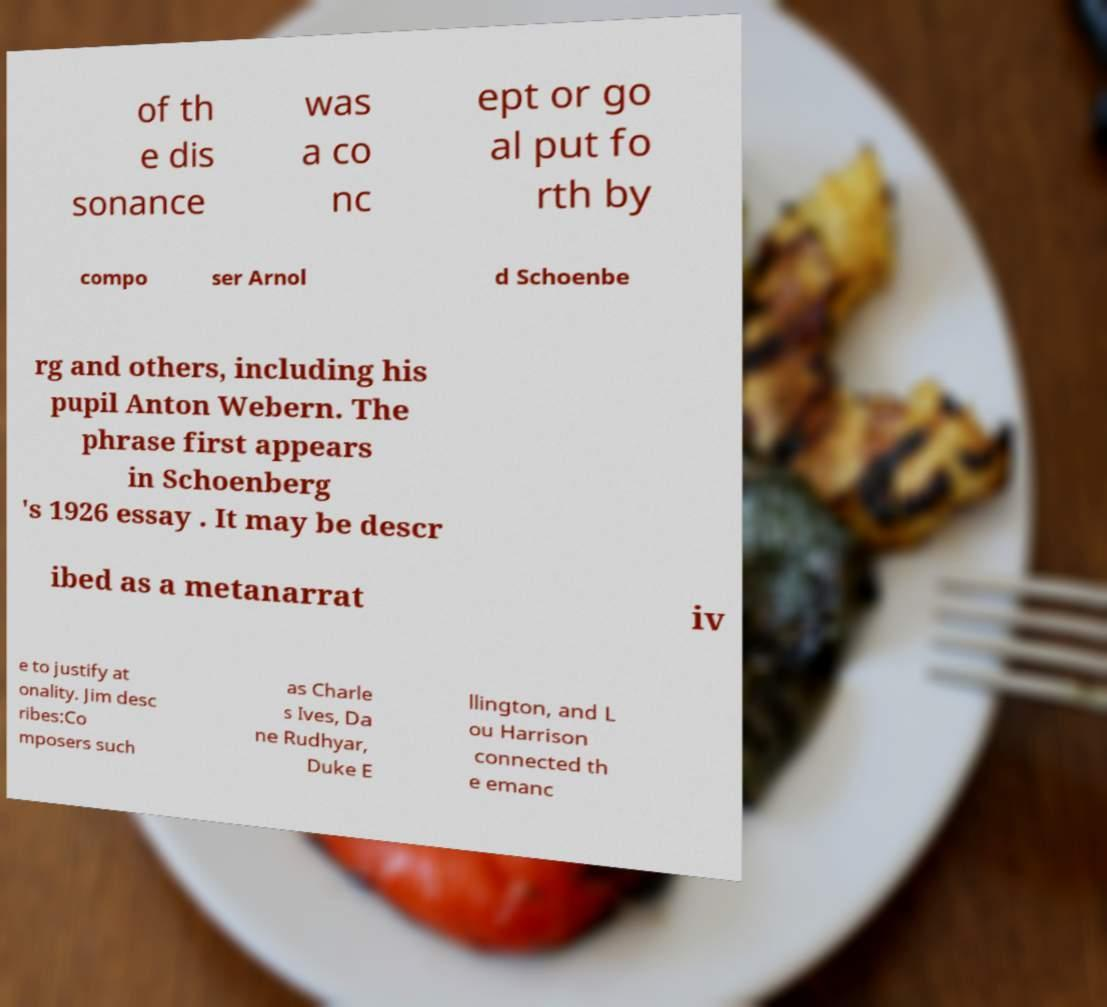Can you accurately transcribe the text from the provided image for me? of th e dis sonance was a co nc ept or go al put fo rth by compo ser Arnol d Schoenbe rg and others, including his pupil Anton Webern. The phrase first appears in Schoenberg 's 1926 essay . It may be descr ibed as a metanarrat iv e to justify at onality. Jim desc ribes:Co mposers such as Charle s Ives, Da ne Rudhyar, Duke E llington, and L ou Harrison connected th e emanc 